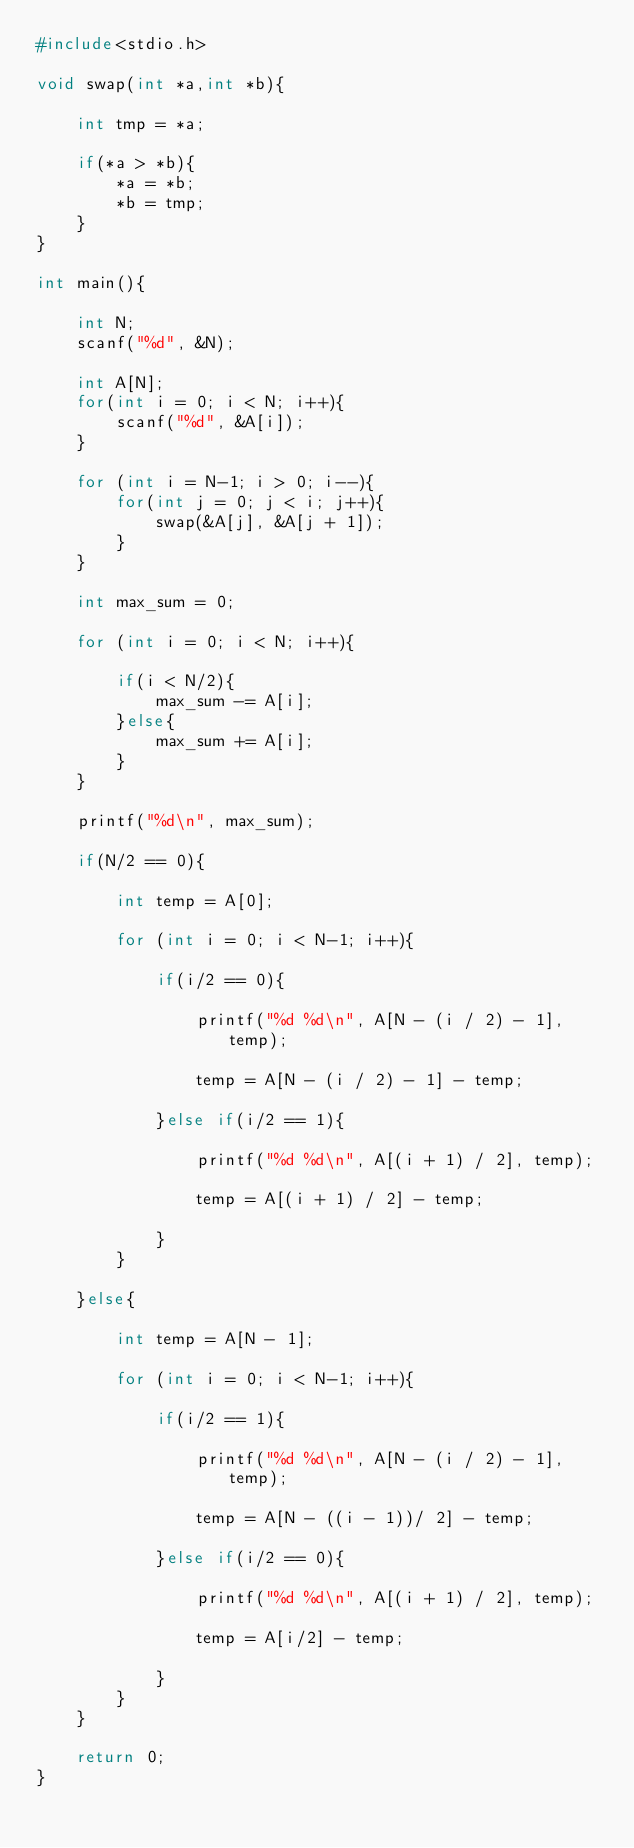<code> <loc_0><loc_0><loc_500><loc_500><_C_>#include<stdio.h>

void swap(int *a,int *b){

    int tmp = *a;

    if(*a > *b){
        *a = *b;
        *b = tmp;
    }
}

int main(){

    int N;
    scanf("%d", &N);

    int A[N];
    for(int i = 0; i < N; i++){
        scanf("%d", &A[i]);
    }

    for (int i = N-1; i > 0; i--){
        for(int j = 0; j < i; j++){
            swap(&A[j], &A[j + 1]);
        }
    }

    int max_sum = 0;

    for (int i = 0; i < N; i++){

        if(i < N/2){
            max_sum -= A[i];
        }else{
            max_sum += A[i];
        }
    }

    printf("%d\n", max_sum);

    if(N/2 == 0){

        int temp = A[0];

        for (int i = 0; i < N-1; i++){

            if(i/2 == 0){

                printf("%d %d\n", A[N - (i / 2) - 1], temp);

                temp = A[N - (i / 2) - 1] - temp;

            }else if(i/2 == 1){

                printf("%d %d\n", A[(i + 1) / 2], temp);

                temp = A[(i + 1) / 2] - temp;

            }
        }

    }else{

        int temp = A[N - 1];

        for (int i = 0; i < N-1; i++){

            if(i/2 == 1){

                printf("%d %d\n", A[N - (i / 2) - 1], temp);

                temp = A[N - ((i - 1))/ 2] - temp;

            }else if(i/2 == 0){

                printf("%d %d\n", A[(i + 1) / 2], temp);

                temp = A[i/2] - temp;

            }
        }
    }

    return 0;
}</code> 